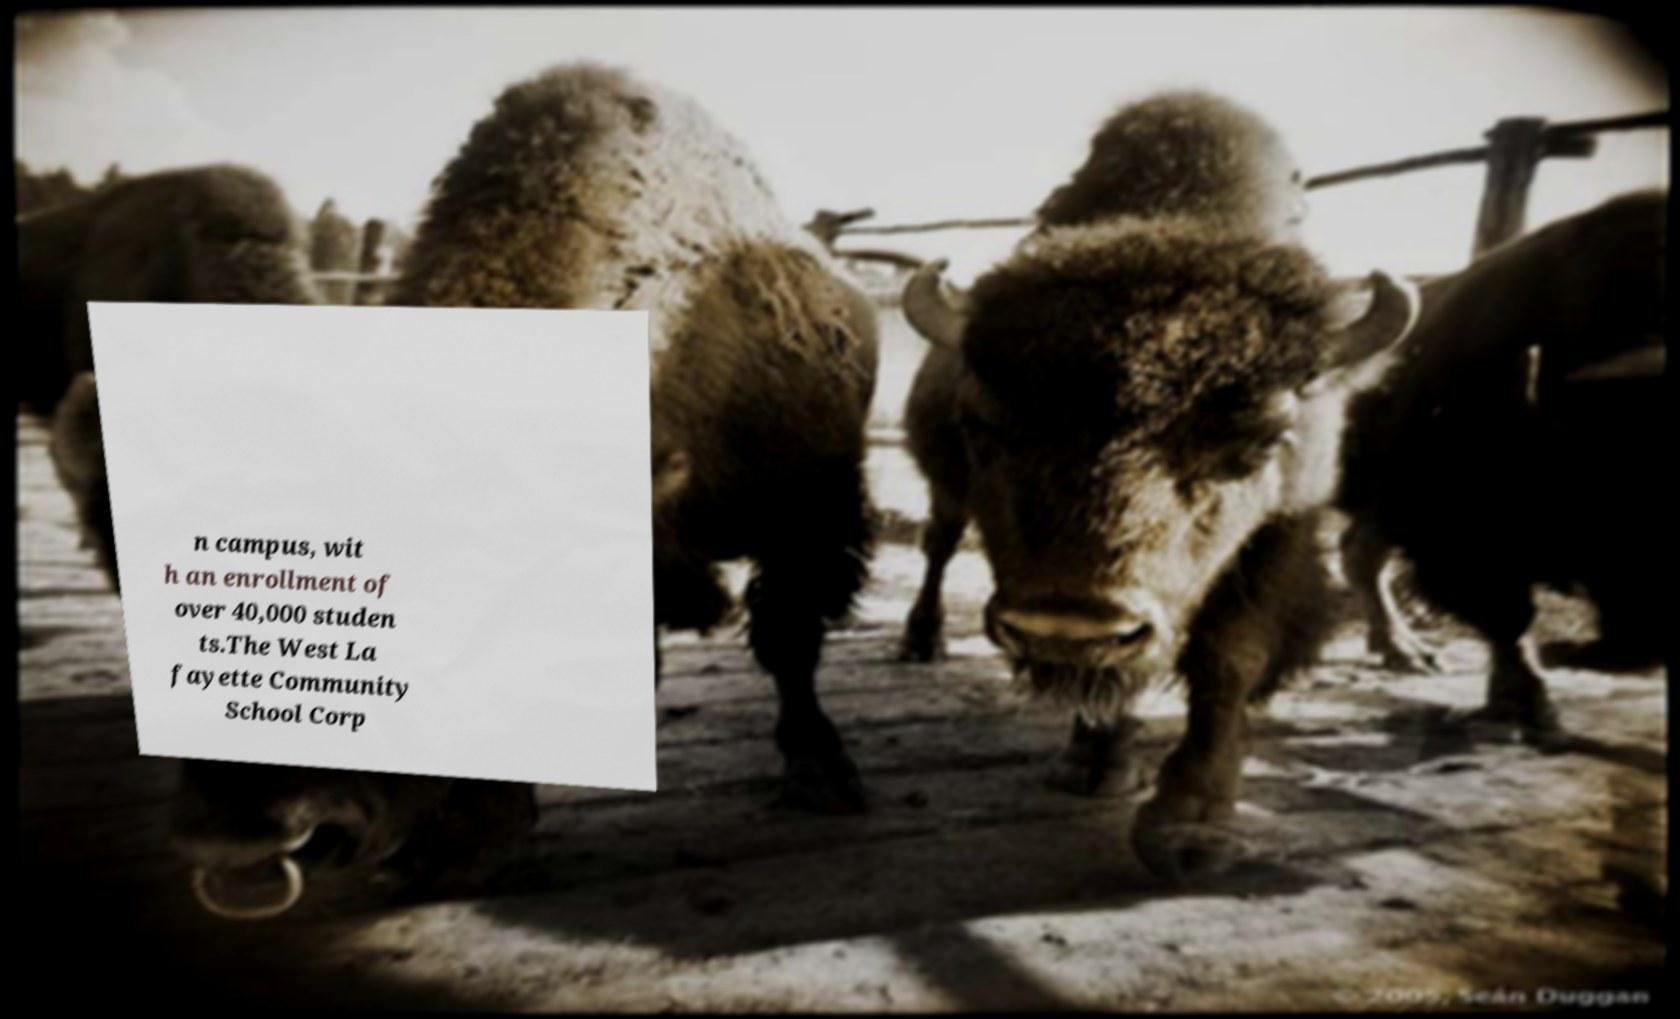Please read and relay the text visible in this image. What does it say? n campus, wit h an enrollment of over 40,000 studen ts.The West La fayette Community School Corp 